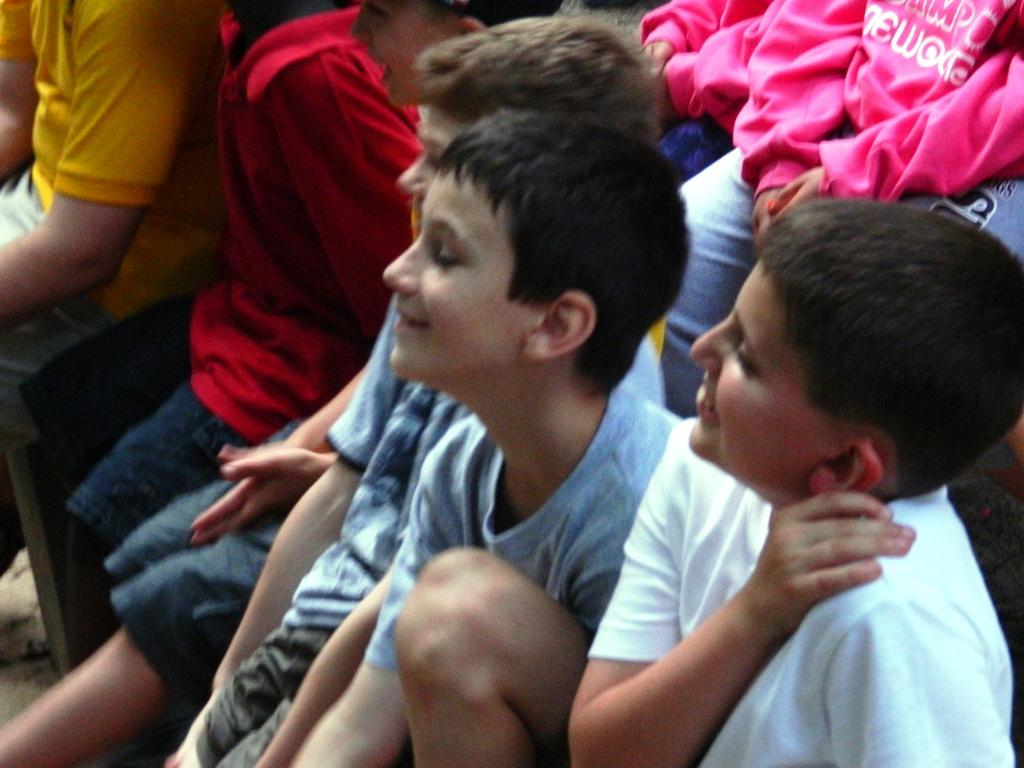Who is present in the image? There are children in the image. What are the children wearing? The children are wearing pink, red, yellow, blue, and white colored dresses. What are the children doing in the image? The children are sitting. What is the facial expression of the children? The children are smiling. What type of flesh can be seen on the children's faces in the image? There is no mention of flesh or any specific facial features in the image; it only states that the children are smiling. 